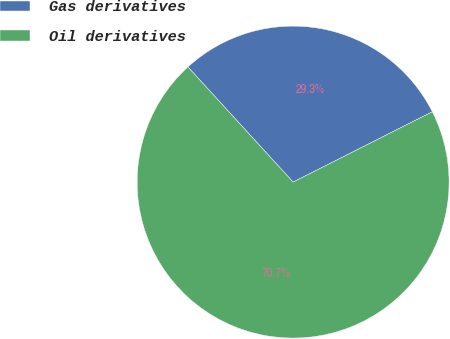Convert chart to OTSL. <chart><loc_0><loc_0><loc_500><loc_500><pie_chart><fcel>Gas derivatives<fcel>Oil derivatives<nl><fcel>29.34%<fcel>70.66%<nl></chart> 